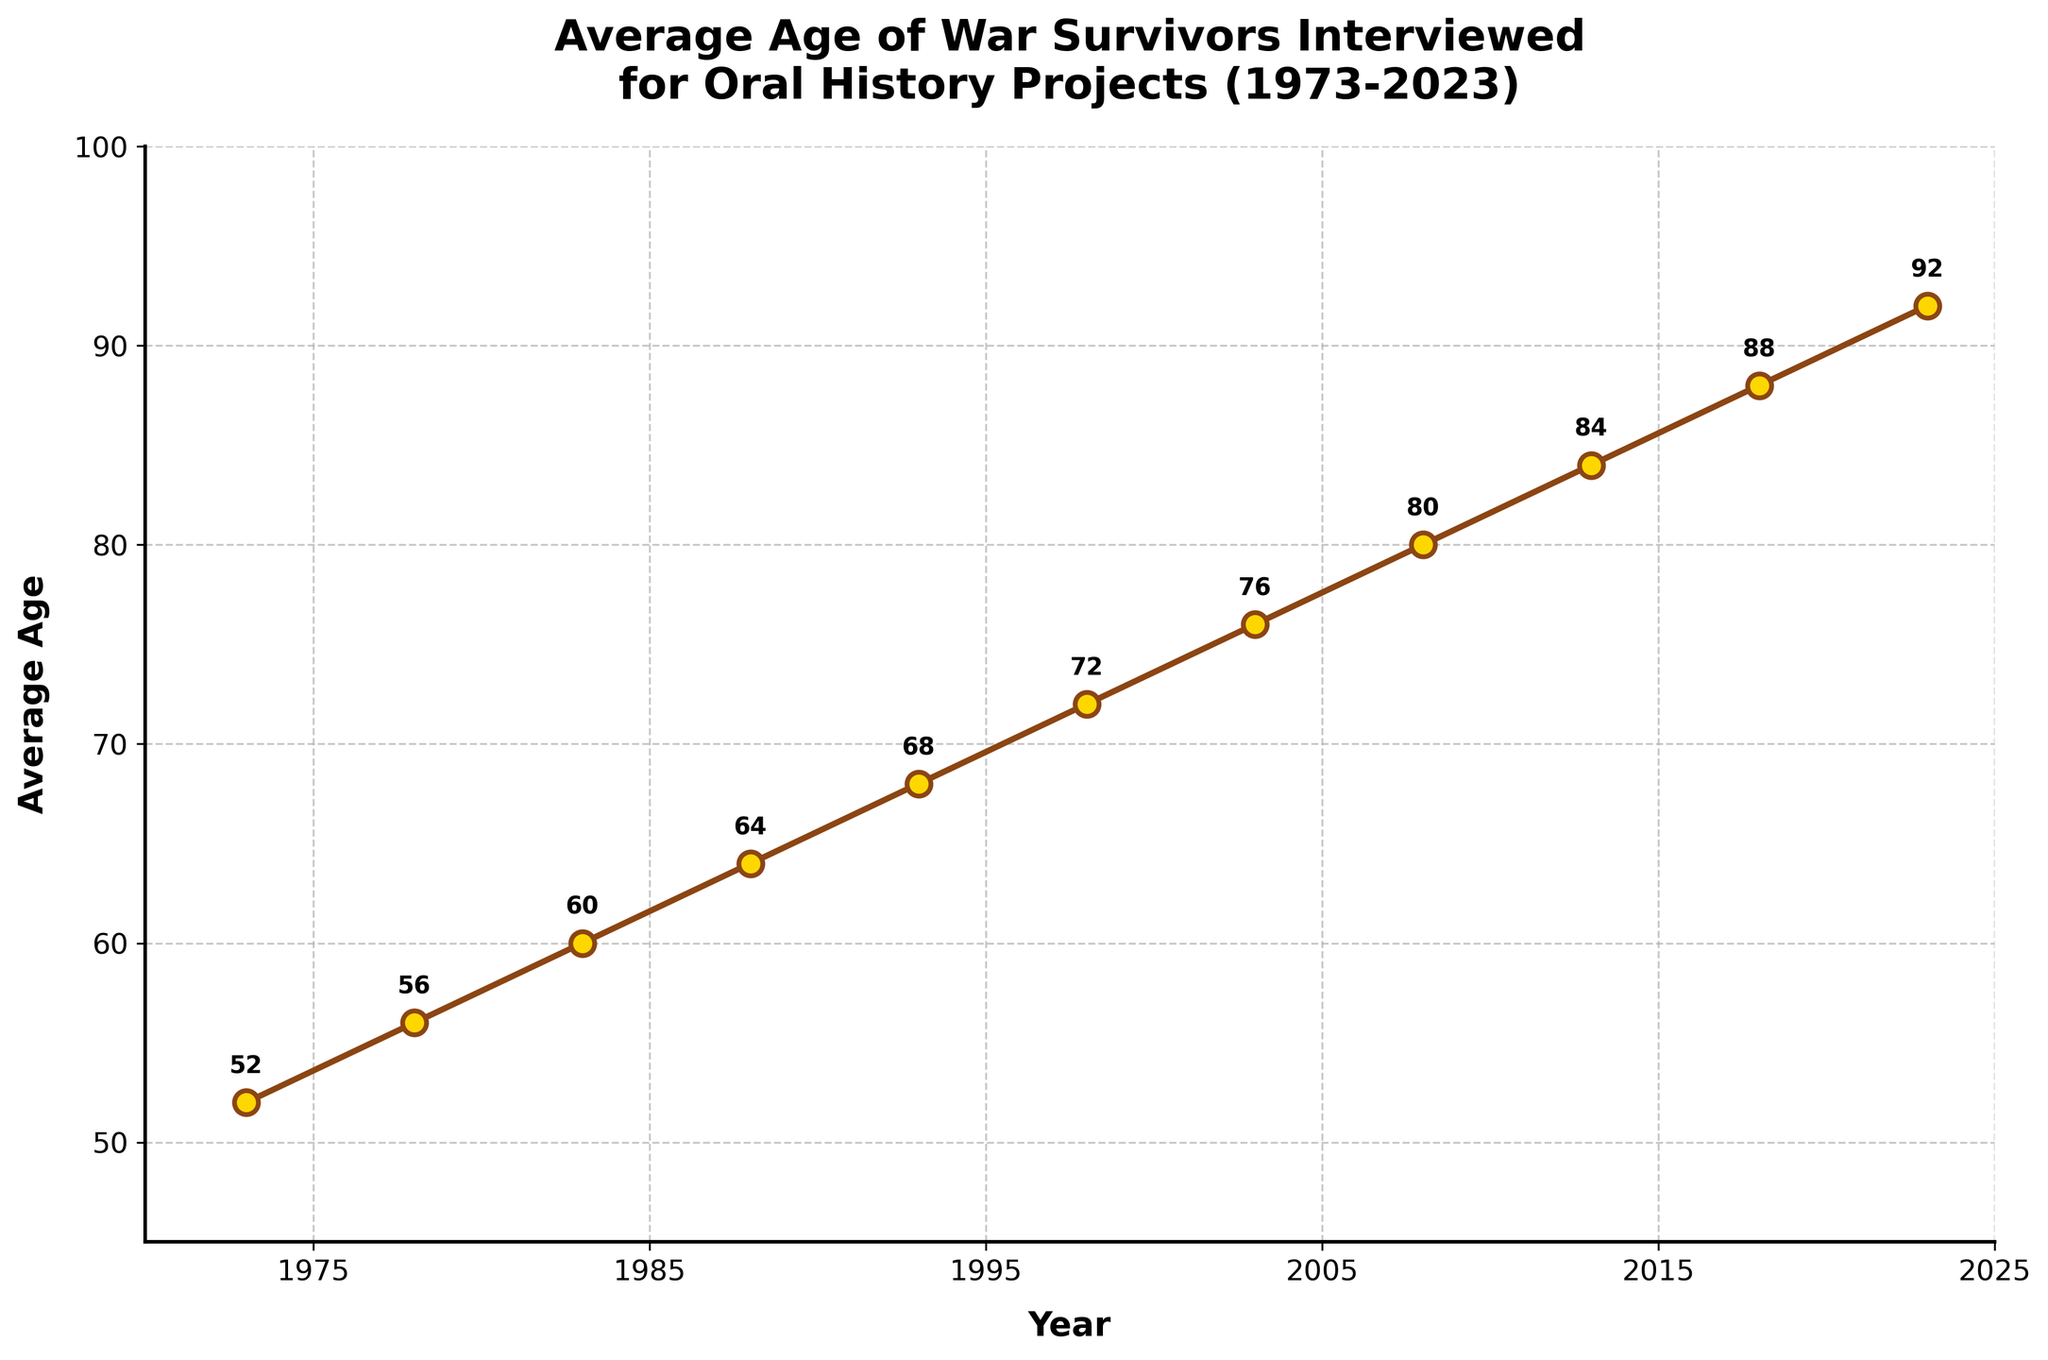What was the average age of war survivors interviewed in 1988? The year 1988 corresponds to a point on the line chart. The labeled data at that point shows the average age.
Answer: 64 How much did the average age increase from 1973 to 2023? The average age in 1973 was 52, and in 2023 it was 92. Subtract 52 from 92 to find the difference.
Answer: 40 What is the trend in the average age of war survivors interviewed over the years? Observe the line chart from 1973 to 2023. The average age consistently increases over the years.
Answer: Increasing Between which years did the average age first exceed 70? Locate the years on the line chart. In 1998, the average age was 72, the first year when it exceeded 70.
Answer: 1998 How many years does it take for the average age to increase by 4 years? Identify the increments in average age across the years. On average, the line chart shows a 4-year increase approximately every 5 years.
Answer: 5 years Which year had the smallest increase in average age compared to the previous data point? Compare consecutive data points on the line chart. The smallest increase is between 2018 and 2023 (4 years).
Answer: 2018 to 2023 What is the average age of war survivors interviewed in the mid-point year of the dataset, 1998? Locate the year 1998 on the line chart and check the label for the average age.
Answer: 72 How does the average age in 2023 compare to that in 1973? Look at the average ages in 1973 and 2023 and compare the values. 2023 has a higher average age (92) compared to 1973 (52).
Answer: Higher By how much did the average age of war survivors interviewed increase between the mid-point years, 1988 and 2008? The average age in 1988 was 64, and in 2008 it was 80. Subtract 64 from 80 to find the increase.
Answer: 16 